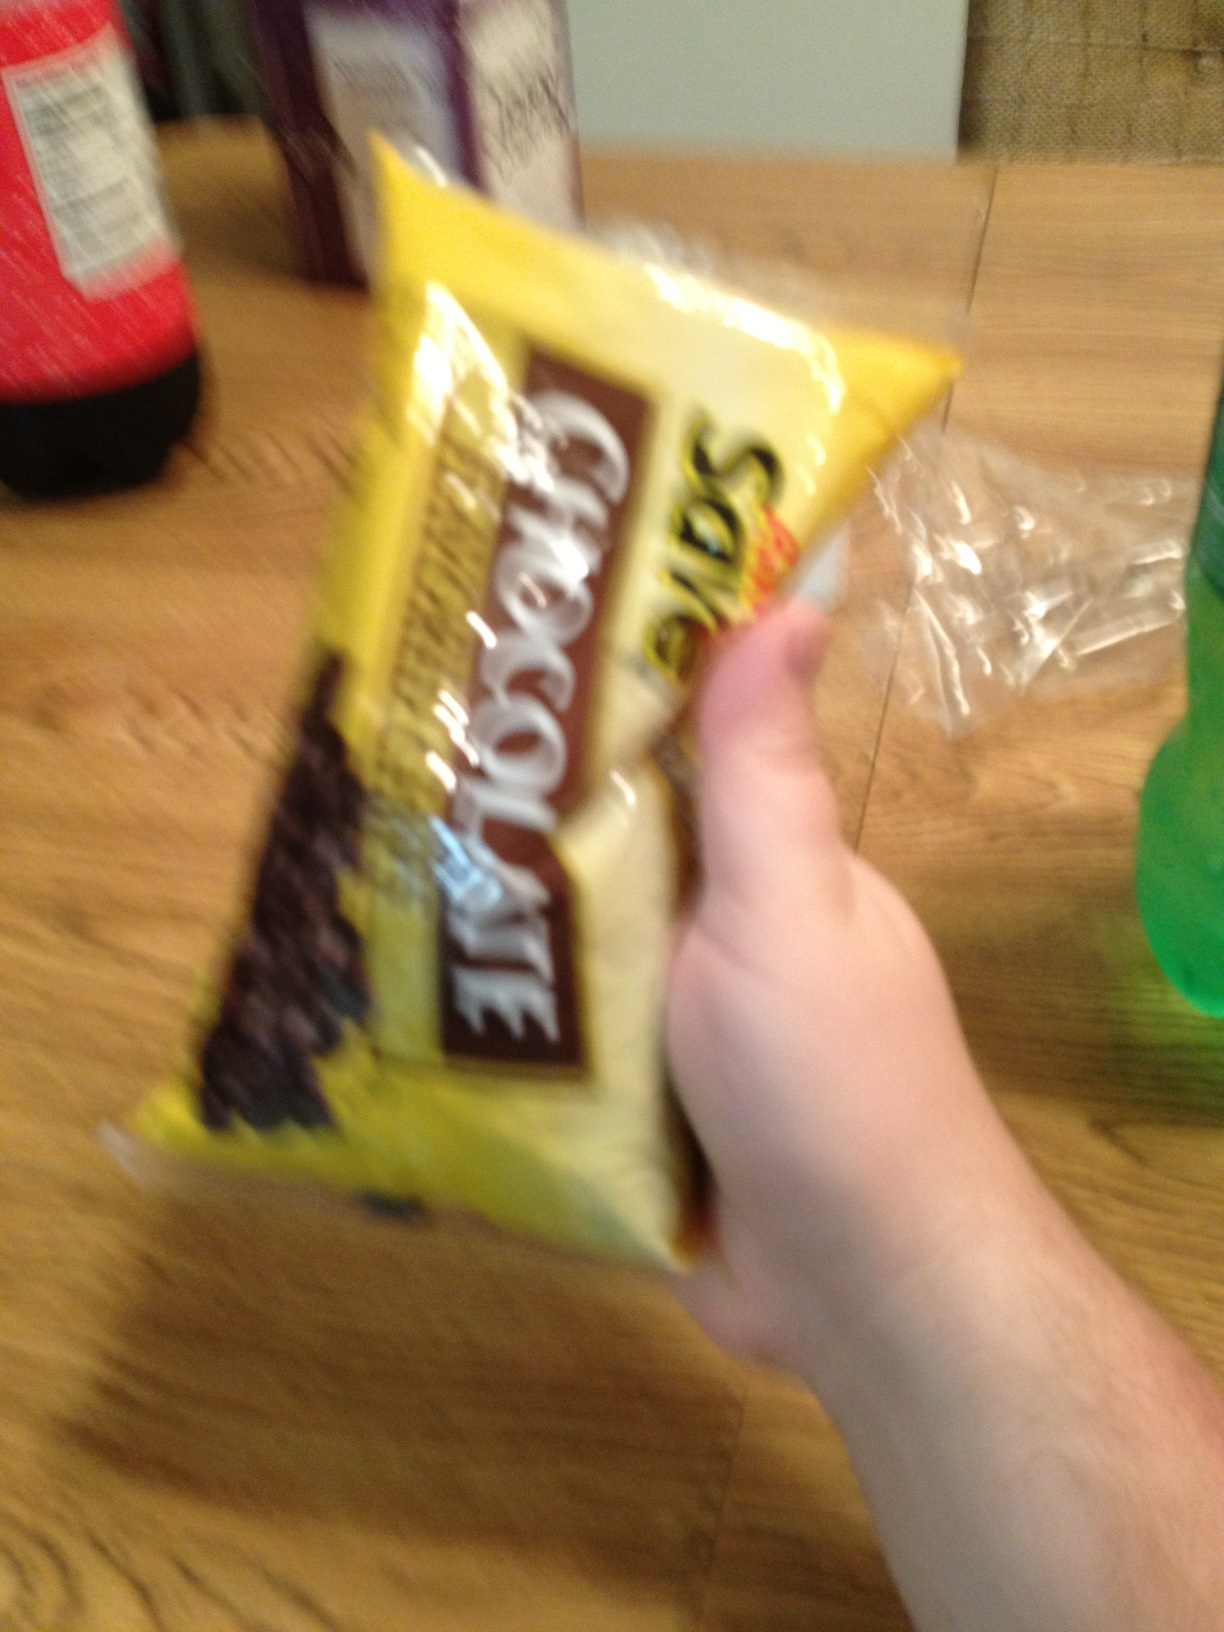What kind of chips are these? The 'chips' in the image are actually chocolate chips, often used in baking cookies and other sweet treats. They are not the fried potato chips commonly referred to in snack contexts. 